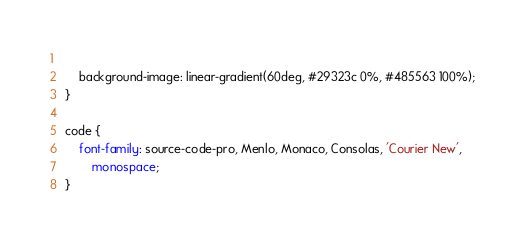<code> <loc_0><loc_0><loc_500><loc_500><_CSS_>    
    background-image: linear-gradient(60deg, #29323c 0%, #485563 100%);
}

code {
    font-family: source-code-pro, Menlo, Monaco, Consolas, 'Courier New',
        monospace;
}
</code> 